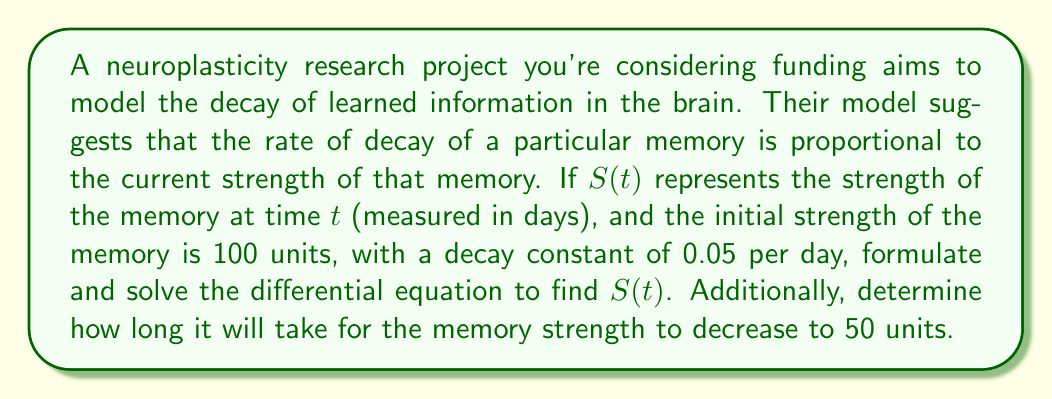Give your solution to this math problem. Let's approach this step-by-step:

1) First, we need to formulate the differential equation. The rate of decay is proportional to the current strength, so we can write:

   $$\frac{dS}{dt} = -kS$$

   where $k$ is the decay constant, 0.05 per day in this case.

2) This is a separable first-order differential equation. We can solve it as follows:

   $$\frac{dS}{S} = -k dt$$

3) Integrating both sides:

   $$\int \frac{dS}{S} = -k \int dt$$

   $$\ln|S| = -kt + C$$

4) Solving for $S$:

   $$S = e^{-kt + C} = Ae^{-kt}$$

   where $A = e^C$ is a constant we'll determine from the initial condition.

5) We're given that $S(0) = 100$, so:

   $$100 = Ae^{-k(0)} = A$$

6) Therefore, our solution is:

   $$S(t) = 100e^{-0.05t}$$

7) To find when the memory strength decreases to 50 units, we solve:

   $$50 = 100e^{-0.05t}$$

8) Dividing both sides by 100:

   $$0.5 = e^{-0.05t}$$

9) Taking the natural log of both sides:

   $$\ln(0.5) = -0.05t$$

10) Solving for $t$:

    $$t = -\frac{\ln(0.5)}{0.05} \approx 13.86 \text{ days}$$
Answer: The strength of the memory at time $t$ is given by $S(t) = 100e^{-0.05t}$, where $t$ is measured in days. The memory strength will decrease to 50 units after approximately 13.86 days. 